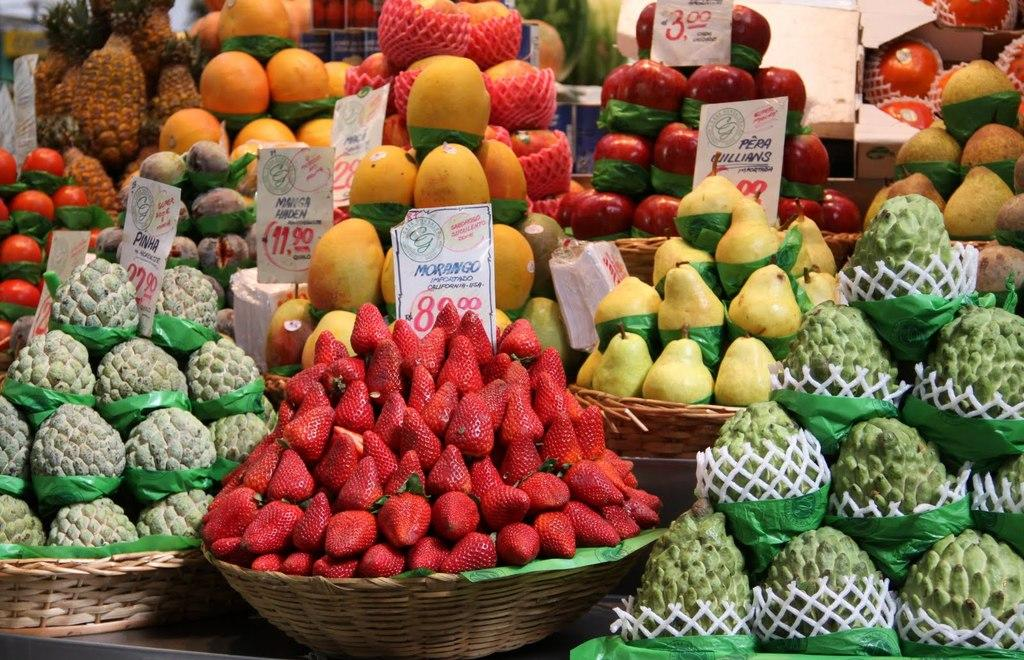What type of food can be seen in the image? There are fruits in the image. Can you describe the appearance of the fruits? The fruits are in multiple colors. What else is present in the image besides the fruits? There are white-colored boards in the image. How are the fruits arranged or stored in the image? The fruits are in baskets. Can you tell me how many mines are visible in the image? There are no mines present in the image; it features fruits in baskets and white-colored boards. What type of dock is shown in the image? There is no dock present in the image. 